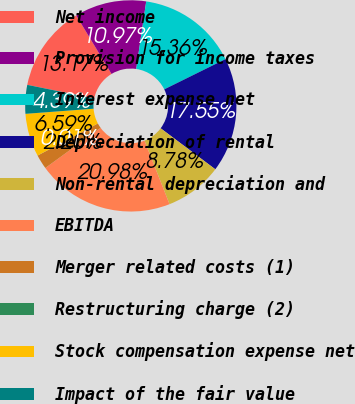Convert chart. <chart><loc_0><loc_0><loc_500><loc_500><pie_chart><fcel>Net income<fcel>Provision for income taxes<fcel>Interest expense net<fcel>Depreciation of rental<fcel>Non-rental depreciation and<fcel>EBITDA<fcel>Merger related costs (1)<fcel>Restructuring charge (2)<fcel>Stock compensation expense net<fcel>Impact of the fair value<nl><fcel>13.17%<fcel>10.97%<fcel>15.36%<fcel>17.55%<fcel>8.78%<fcel>20.98%<fcel>2.2%<fcel>0.01%<fcel>6.59%<fcel>4.39%<nl></chart> 